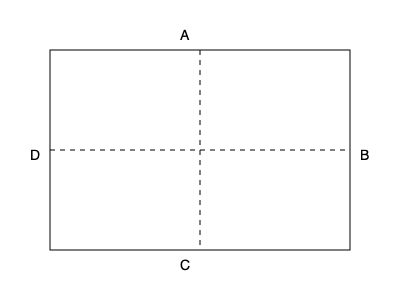Imagine you're holding a Los Hermanos concert ticket stub. If you fold it along the vertical dashed line and then along the horizontal dashed line, which corner will end up on top? To solve this problem, we need to visualize the folding process step by step:

1. The ticket stub is represented by the rectangle in the diagram.
2. The first fold is along the vertical dashed line, which divides the stub into two equal halves.
   - This fold will bring the right side (B) over to the left side (D).
3. After the first fold, corners A and B will be on top of D and C, respectively.
4. The second fold is along the horizontal dashed line, which folds the stub in half vertically.
   - This fold will bring the top half down over the bottom half.
5. After the second fold:
   - Corner A will be folded under and inside.
   - Corner B, which was on top of C after the first fold, will now be on the very top.
   - Corner C will be on the bottom.
   - Corner D will be folded under and inside.

Therefore, after both folds are completed, corner B will end up on top.
Answer: B 